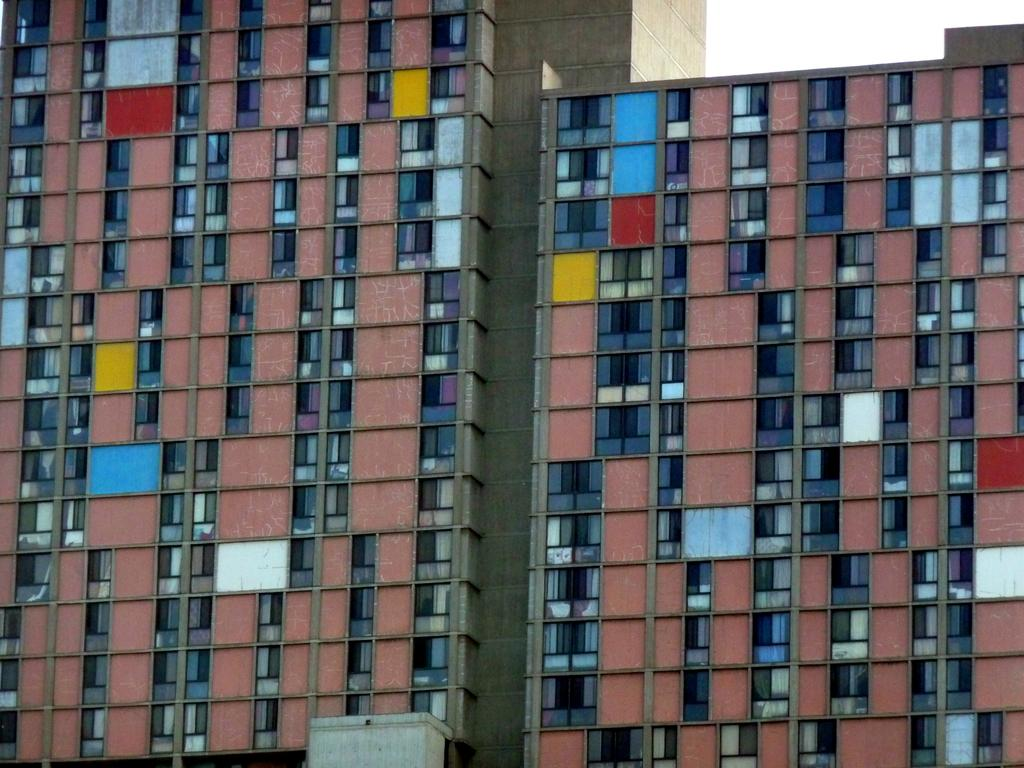Where was the image taken from? The image was taken from outside of a building. What can be seen in the image? There is a building in the image. What material is the window in the image made of? The window in the image is made of glass. What type of anger can be seen on the nation's face in the image? There is no nation or face present in the image; it only features a building and a glass window. 